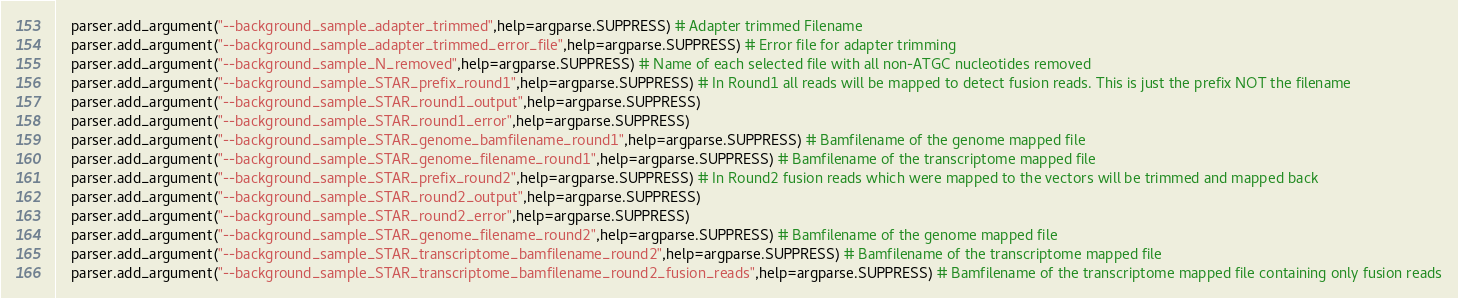Convert code to text. <code><loc_0><loc_0><loc_500><loc_500><_Python_>    parser.add_argument("--background_sample_adapter_trimmed",help=argparse.SUPPRESS) # Adapter trimmed Filename
    parser.add_argument("--background_sample_adapter_trimmed_error_file",help=argparse.SUPPRESS) # Error file for adapter trimming
    parser.add_argument("--background_sample_N_removed",help=argparse.SUPPRESS) # Name of each selected file with all non-ATGC nucleotides removed
    parser.add_argument("--background_sample_STAR_prefix_round1",help=argparse.SUPPRESS) # In Round1 all reads will be mapped to detect fusion reads. This is just the prefix NOT the filename
    parser.add_argument("--background_sample_STAR_round1_output",help=argparse.SUPPRESS)
    parser.add_argument("--background_sample_STAR_round1_error",help=argparse.SUPPRESS)
    parser.add_argument("--background_sample_STAR_genome_bamfilename_round1",help=argparse.SUPPRESS) # Bamfilename of the genome mapped file
    parser.add_argument("--background_sample_STAR_genome_filename_round1",help=argparse.SUPPRESS) # Bamfilename of the transcriptome mapped file
    parser.add_argument("--background_sample_STAR_prefix_round2",help=argparse.SUPPRESS) # In Round2 fusion reads which were mapped to the vectors will be trimmed and mapped back
    parser.add_argument("--background_sample_STAR_round2_output",help=argparse.SUPPRESS)
    parser.add_argument("--background_sample_STAR_round2_error",help=argparse.SUPPRESS)
    parser.add_argument("--background_sample_STAR_genome_filename_round2",help=argparse.SUPPRESS) # Bamfilename of the genome mapped file
    parser.add_argument("--background_sample_STAR_transcriptome_bamfilename_round2",help=argparse.SUPPRESS) # Bamfilename of the transcriptome mapped file
    parser.add_argument("--background_sample_STAR_transcriptome_bamfilename_round2_fusion_reads",help=argparse.SUPPRESS) # Bamfilename of the transcriptome mapped file containing only fusion reads</code> 